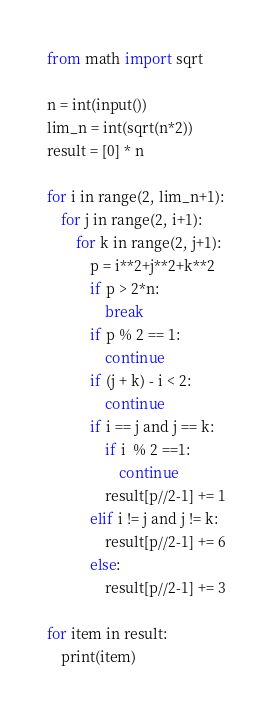<code> <loc_0><loc_0><loc_500><loc_500><_Python_>from math import sqrt

n = int(input())
lim_n = int(sqrt(n*2))
result = [0] * n

for i in range(2, lim_n+1):
    for j in range(2, i+1):
        for k in range(2, j+1):
            p = i**2+j**2+k**2
            if p > 2*n:
                break
            if p % 2 == 1:
                continue
            if (j + k) - i < 2:
                continue
            if i == j and j == k:
                if i  % 2 ==1:
                    continue
                result[p//2-1] += 1
            elif i != j and j != k:
                result[p//2-1] += 6
            else:
                result[p//2-1] += 3

for item in result:
    print(item)</code> 